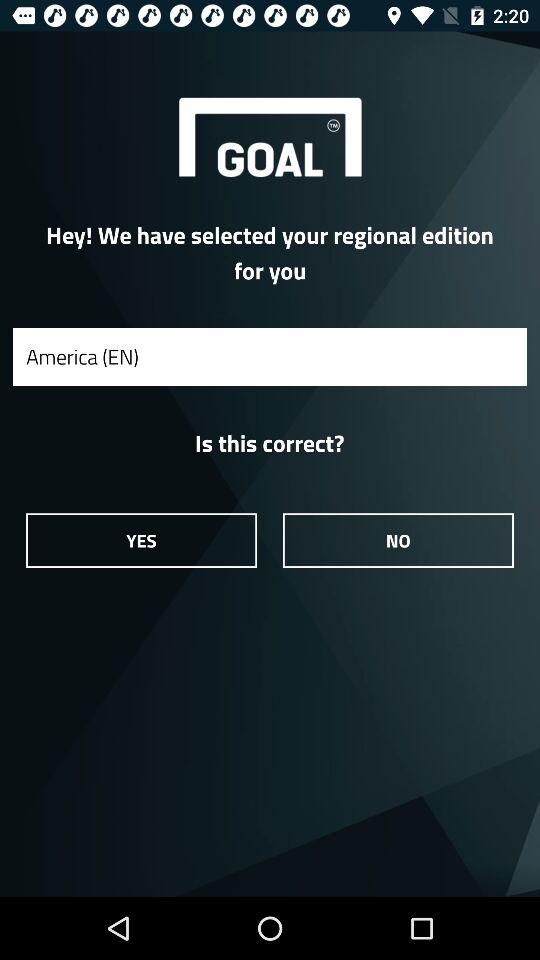What is the application name? The application name is "GOAL". 